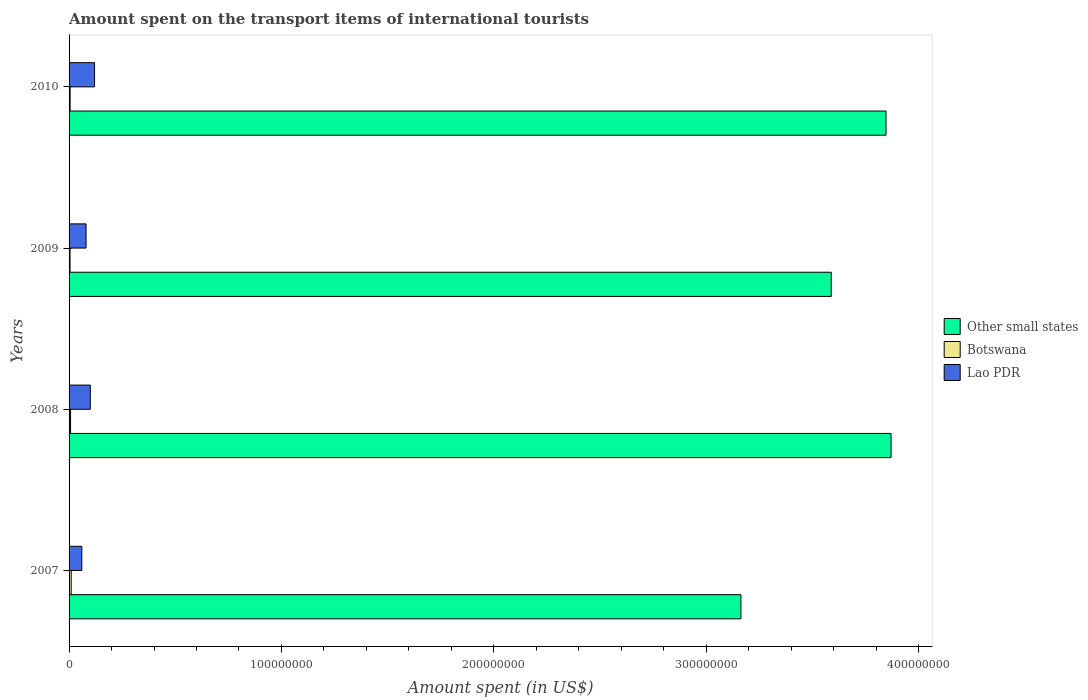How many bars are there on the 1st tick from the top?
Offer a terse response. 3. How many bars are there on the 2nd tick from the bottom?
Keep it short and to the point. 3. What is the label of the 3rd group of bars from the top?
Make the answer very short. 2008. What is the amount spent on the transport items of international tourists in Other small states in 2009?
Provide a succinct answer. 3.59e+08. Across all years, what is the maximum amount spent on the transport items of international tourists in Lao PDR?
Provide a short and direct response. 1.20e+07. Across all years, what is the minimum amount spent on the transport items of international tourists in Other small states?
Provide a succinct answer. 3.16e+08. What is the total amount spent on the transport items of international tourists in Lao PDR in the graph?
Provide a short and direct response. 3.60e+07. What is the difference between the amount spent on the transport items of international tourists in Botswana in 2007 and that in 2008?
Your response must be concise. 3.00e+05. What is the difference between the amount spent on the transport items of international tourists in Other small states in 2010 and the amount spent on the transport items of international tourists in Botswana in 2009?
Provide a short and direct response. 3.84e+08. What is the average amount spent on the transport items of international tourists in Lao PDR per year?
Ensure brevity in your answer.  9.00e+06. In the year 2010, what is the difference between the amount spent on the transport items of international tourists in Botswana and amount spent on the transport items of international tourists in Other small states?
Provide a short and direct response. -3.84e+08. What is the ratio of the amount spent on the transport items of international tourists in Lao PDR in 2009 to that in 2010?
Provide a succinct answer. 0.67. Is the amount spent on the transport items of international tourists in Botswana in 2008 less than that in 2010?
Provide a succinct answer. No. What is the difference between the highest and the second highest amount spent on the transport items of international tourists in Botswana?
Provide a succinct answer. 3.00e+05. What is the difference between the highest and the lowest amount spent on the transport items of international tourists in Botswana?
Your response must be concise. 5.50e+05. What does the 3rd bar from the top in 2008 represents?
Your response must be concise. Other small states. What does the 2nd bar from the bottom in 2008 represents?
Ensure brevity in your answer.  Botswana. How many bars are there?
Your answer should be very brief. 12. Are all the bars in the graph horizontal?
Provide a succinct answer. Yes. How many years are there in the graph?
Give a very brief answer. 4. What is the difference between two consecutive major ticks on the X-axis?
Your response must be concise. 1.00e+08. Are the values on the major ticks of X-axis written in scientific E-notation?
Your answer should be compact. No. Does the graph contain any zero values?
Provide a short and direct response. No. How are the legend labels stacked?
Offer a very short reply. Vertical. What is the title of the graph?
Make the answer very short. Amount spent on the transport items of international tourists. What is the label or title of the X-axis?
Keep it short and to the point. Amount spent (in US$). What is the label or title of the Y-axis?
Give a very brief answer. Years. What is the Amount spent (in US$) in Other small states in 2007?
Ensure brevity in your answer.  3.16e+08. What is the Amount spent (in US$) of Botswana in 2007?
Offer a terse response. 1.00e+06. What is the Amount spent (in US$) of Lao PDR in 2007?
Your answer should be compact. 6.00e+06. What is the Amount spent (in US$) in Other small states in 2008?
Offer a very short reply. 3.87e+08. What is the Amount spent (in US$) in Botswana in 2008?
Your answer should be compact. 7.00e+05. What is the Amount spent (in US$) in Other small states in 2009?
Provide a short and direct response. 3.59e+08. What is the Amount spent (in US$) in Botswana in 2009?
Keep it short and to the point. 4.50e+05. What is the Amount spent (in US$) of Lao PDR in 2009?
Make the answer very short. 8.00e+06. What is the Amount spent (in US$) in Other small states in 2010?
Keep it short and to the point. 3.85e+08. What is the Amount spent (in US$) of Botswana in 2010?
Offer a terse response. 5.00e+05. What is the Amount spent (in US$) of Lao PDR in 2010?
Keep it short and to the point. 1.20e+07. Across all years, what is the maximum Amount spent (in US$) in Other small states?
Make the answer very short. 3.87e+08. Across all years, what is the maximum Amount spent (in US$) of Botswana?
Ensure brevity in your answer.  1.00e+06. Across all years, what is the minimum Amount spent (in US$) of Other small states?
Offer a very short reply. 3.16e+08. Across all years, what is the minimum Amount spent (in US$) in Lao PDR?
Give a very brief answer. 6.00e+06. What is the total Amount spent (in US$) in Other small states in the graph?
Keep it short and to the point. 1.45e+09. What is the total Amount spent (in US$) in Botswana in the graph?
Offer a terse response. 2.65e+06. What is the total Amount spent (in US$) of Lao PDR in the graph?
Ensure brevity in your answer.  3.60e+07. What is the difference between the Amount spent (in US$) of Other small states in 2007 and that in 2008?
Make the answer very short. -7.07e+07. What is the difference between the Amount spent (in US$) in Botswana in 2007 and that in 2008?
Keep it short and to the point. 3.00e+05. What is the difference between the Amount spent (in US$) of Lao PDR in 2007 and that in 2008?
Make the answer very short. -4.00e+06. What is the difference between the Amount spent (in US$) in Other small states in 2007 and that in 2009?
Ensure brevity in your answer.  -4.25e+07. What is the difference between the Amount spent (in US$) in Botswana in 2007 and that in 2009?
Offer a terse response. 5.50e+05. What is the difference between the Amount spent (in US$) in Lao PDR in 2007 and that in 2009?
Keep it short and to the point. -2.00e+06. What is the difference between the Amount spent (in US$) in Other small states in 2007 and that in 2010?
Keep it short and to the point. -6.83e+07. What is the difference between the Amount spent (in US$) of Lao PDR in 2007 and that in 2010?
Make the answer very short. -6.00e+06. What is the difference between the Amount spent (in US$) of Other small states in 2008 and that in 2009?
Give a very brief answer. 2.82e+07. What is the difference between the Amount spent (in US$) in Lao PDR in 2008 and that in 2009?
Offer a very short reply. 2.00e+06. What is the difference between the Amount spent (in US$) in Other small states in 2008 and that in 2010?
Give a very brief answer. 2.37e+06. What is the difference between the Amount spent (in US$) in Other small states in 2009 and that in 2010?
Give a very brief answer. -2.58e+07. What is the difference between the Amount spent (in US$) of Other small states in 2007 and the Amount spent (in US$) of Botswana in 2008?
Make the answer very short. 3.16e+08. What is the difference between the Amount spent (in US$) in Other small states in 2007 and the Amount spent (in US$) in Lao PDR in 2008?
Offer a very short reply. 3.06e+08. What is the difference between the Amount spent (in US$) of Botswana in 2007 and the Amount spent (in US$) of Lao PDR in 2008?
Keep it short and to the point. -9.00e+06. What is the difference between the Amount spent (in US$) in Other small states in 2007 and the Amount spent (in US$) in Botswana in 2009?
Provide a short and direct response. 3.16e+08. What is the difference between the Amount spent (in US$) of Other small states in 2007 and the Amount spent (in US$) of Lao PDR in 2009?
Offer a very short reply. 3.08e+08. What is the difference between the Amount spent (in US$) in Botswana in 2007 and the Amount spent (in US$) in Lao PDR in 2009?
Offer a terse response. -7.00e+06. What is the difference between the Amount spent (in US$) in Other small states in 2007 and the Amount spent (in US$) in Botswana in 2010?
Give a very brief answer. 3.16e+08. What is the difference between the Amount spent (in US$) of Other small states in 2007 and the Amount spent (in US$) of Lao PDR in 2010?
Your answer should be compact. 3.04e+08. What is the difference between the Amount spent (in US$) in Botswana in 2007 and the Amount spent (in US$) in Lao PDR in 2010?
Offer a very short reply. -1.10e+07. What is the difference between the Amount spent (in US$) in Other small states in 2008 and the Amount spent (in US$) in Botswana in 2009?
Keep it short and to the point. 3.87e+08. What is the difference between the Amount spent (in US$) of Other small states in 2008 and the Amount spent (in US$) of Lao PDR in 2009?
Your response must be concise. 3.79e+08. What is the difference between the Amount spent (in US$) in Botswana in 2008 and the Amount spent (in US$) in Lao PDR in 2009?
Offer a terse response. -7.30e+06. What is the difference between the Amount spent (in US$) of Other small states in 2008 and the Amount spent (in US$) of Botswana in 2010?
Offer a very short reply. 3.87e+08. What is the difference between the Amount spent (in US$) of Other small states in 2008 and the Amount spent (in US$) of Lao PDR in 2010?
Offer a very short reply. 3.75e+08. What is the difference between the Amount spent (in US$) of Botswana in 2008 and the Amount spent (in US$) of Lao PDR in 2010?
Provide a succinct answer. -1.13e+07. What is the difference between the Amount spent (in US$) in Other small states in 2009 and the Amount spent (in US$) in Botswana in 2010?
Your response must be concise. 3.58e+08. What is the difference between the Amount spent (in US$) in Other small states in 2009 and the Amount spent (in US$) in Lao PDR in 2010?
Your answer should be compact. 3.47e+08. What is the difference between the Amount spent (in US$) of Botswana in 2009 and the Amount spent (in US$) of Lao PDR in 2010?
Your answer should be compact. -1.16e+07. What is the average Amount spent (in US$) of Other small states per year?
Your answer should be compact. 3.62e+08. What is the average Amount spent (in US$) of Botswana per year?
Your response must be concise. 6.62e+05. What is the average Amount spent (in US$) in Lao PDR per year?
Provide a succinct answer. 9.00e+06. In the year 2007, what is the difference between the Amount spent (in US$) of Other small states and Amount spent (in US$) of Botswana?
Offer a very short reply. 3.15e+08. In the year 2007, what is the difference between the Amount spent (in US$) in Other small states and Amount spent (in US$) in Lao PDR?
Your response must be concise. 3.10e+08. In the year 2007, what is the difference between the Amount spent (in US$) of Botswana and Amount spent (in US$) of Lao PDR?
Provide a succinct answer. -5.00e+06. In the year 2008, what is the difference between the Amount spent (in US$) in Other small states and Amount spent (in US$) in Botswana?
Your answer should be compact. 3.86e+08. In the year 2008, what is the difference between the Amount spent (in US$) of Other small states and Amount spent (in US$) of Lao PDR?
Provide a succinct answer. 3.77e+08. In the year 2008, what is the difference between the Amount spent (in US$) in Botswana and Amount spent (in US$) in Lao PDR?
Your answer should be very brief. -9.30e+06. In the year 2009, what is the difference between the Amount spent (in US$) of Other small states and Amount spent (in US$) of Botswana?
Your answer should be compact. 3.58e+08. In the year 2009, what is the difference between the Amount spent (in US$) of Other small states and Amount spent (in US$) of Lao PDR?
Keep it short and to the point. 3.51e+08. In the year 2009, what is the difference between the Amount spent (in US$) in Botswana and Amount spent (in US$) in Lao PDR?
Ensure brevity in your answer.  -7.55e+06. In the year 2010, what is the difference between the Amount spent (in US$) in Other small states and Amount spent (in US$) in Botswana?
Give a very brief answer. 3.84e+08. In the year 2010, what is the difference between the Amount spent (in US$) in Other small states and Amount spent (in US$) in Lao PDR?
Your response must be concise. 3.73e+08. In the year 2010, what is the difference between the Amount spent (in US$) in Botswana and Amount spent (in US$) in Lao PDR?
Give a very brief answer. -1.15e+07. What is the ratio of the Amount spent (in US$) in Other small states in 2007 to that in 2008?
Ensure brevity in your answer.  0.82. What is the ratio of the Amount spent (in US$) in Botswana in 2007 to that in 2008?
Your response must be concise. 1.43. What is the ratio of the Amount spent (in US$) of Other small states in 2007 to that in 2009?
Offer a terse response. 0.88. What is the ratio of the Amount spent (in US$) in Botswana in 2007 to that in 2009?
Provide a short and direct response. 2.22. What is the ratio of the Amount spent (in US$) of Lao PDR in 2007 to that in 2009?
Offer a very short reply. 0.75. What is the ratio of the Amount spent (in US$) of Other small states in 2007 to that in 2010?
Ensure brevity in your answer.  0.82. What is the ratio of the Amount spent (in US$) of Botswana in 2007 to that in 2010?
Provide a short and direct response. 2. What is the ratio of the Amount spent (in US$) of Lao PDR in 2007 to that in 2010?
Give a very brief answer. 0.5. What is the ratio of the Amount spent (in US$) in Other small states in 2008 to that in 2009?
Your answer should be very brief. 1.08. What is the ratio of the Amount spent (in US$) of Botswana in 2008 to that in 2009?
Offer a very short reply. 1.56. What is the ratio of the Amount spent (in US$) of Other small states in 2008 to that in 2010?
Provide a short and direct response. 1.01. What is the ratio of the Amount spent (in US$) of Botswana in 2008 to that in 2010?
Provide a succinct answer. 1.4. What is the ratio of the Amount spent (in US$) in Other small states in 2009 to that in 2010?
Offer a terse response. 0.93. What is the difference between the highest and the second highest Amount spent (in US$) in Other small states?
Provide a succinct answer. 2.37e+06. What is the difference between the highest and the lowest Amount spent (in US$) in Other small states?
Your response must be concise. 7.07e+07. 